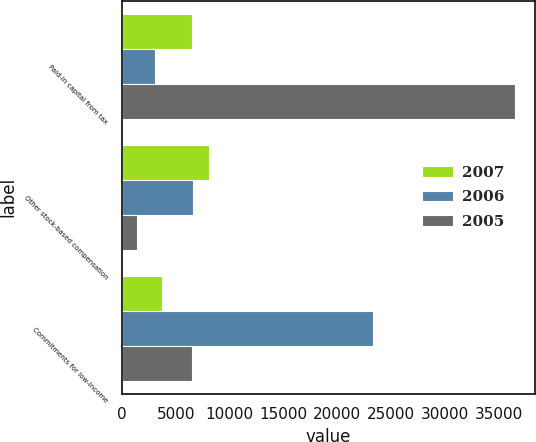<chart> <loc_0><loc_0><loc_500><loc_500><stacked_bar_chart><ecel><fcel>Paid-in capital from tax<fcel>Other stock-based compensation<fcel>Commitments for low-income<nl><fcel>2007<fcel>6460<fcel>8106<fcel>3696<nl><fcel>2006<fcel>3072<fcel>6575<fcel>23320<nl><fcel>2005<fcel>36545<fcel>1375<fcel>6517.5<nl></chart> 